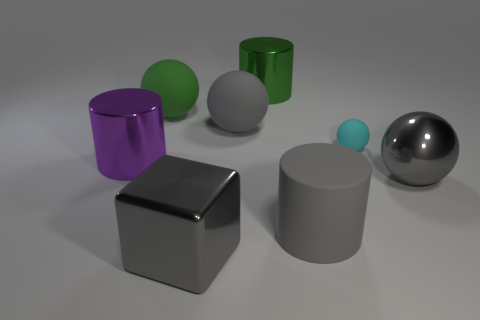What number of other objects are the same color as the block?
Offer a terse response. 3. What size is the shiny thing to the right of the metal cylinder on the right side of the gray cube?
Make the answer very short. Large. Is the number of metal things on the left side of the green shiny cylinder greater than the number of large shiny cylinders right of the large gray cube?
Your answer should be compact. Yes. What number of cubes are either tiny purple matte objects or large objects?
Ensure brevity in your answer.  1. Are there any other things that have the same size as the gray cube?
Make the answer very short. Yes. Do the gray thing right of the small cyan sphere and the purple shiny thing have the same shape?
Make the answer very short. No. The metallic sphere is what color?
Give a very brief answer. Gray. The large shiny thing that is the same shape as the tiny object is what color?
Your answer should be very brief. Gray. What number of green things are the same shape as the large purple metal object?
Make the answer very short. 1. What number of objects are either cyan objects or large green things behind the green matte sphere?
Your response must be concise. 2. 